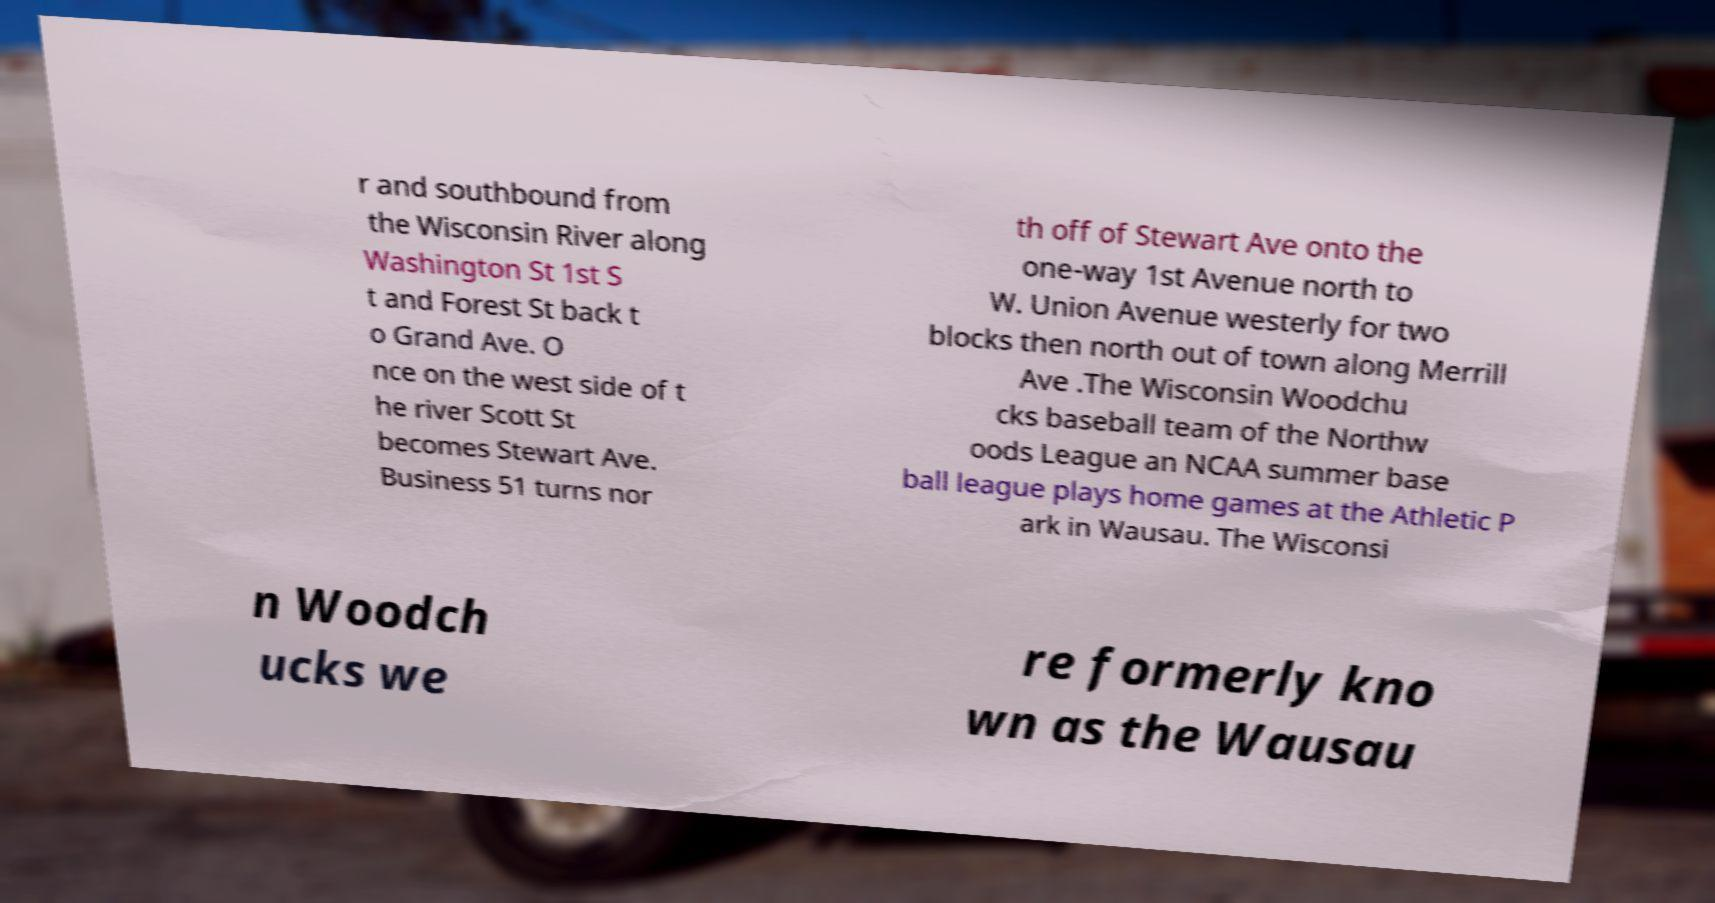Could you extract and type out the text from this image? r and southbound from the Wisconsin River along Washington St 1st S t and Forest St back t o Grand Ave. O nce on the west side of t he river Scott St becomes Stewart Ave. Business 51 turns nor th off of Stewart Ave onto the one-way 1st Avenue north to W. Union Avenue westerly for two blocks then north out of town along Merrill Ave .The Wisconsin Woodchu cks baseball team of the Northw oods League an NCAA summer base ball league plays home games at the Athletic P ark in Wausau. The Wisconsi n Woodch ucks we re formerly kno wn as the Wausau 